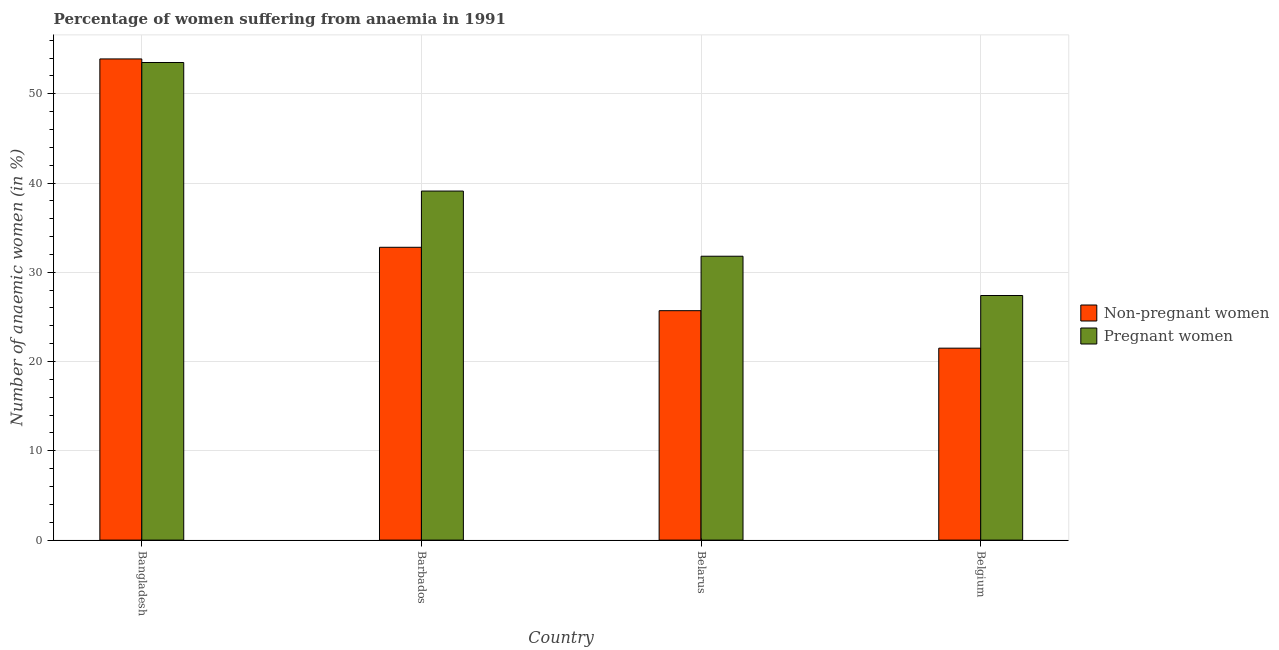How many different coloured bars are there?
Give a very brief answer. 2. Are the number of bars per tick equal to the number of legend labels?
Provide a succinct answer. Yes. How many bars are there on the 1st tick from the right?
Make the answer very short. 2. What is the label of the 3rd group of bars from the left?
Ensure brevity in your answer.  Belarus. What is the percentage of non-pregnant anaemic women in Belarus?
Provide a succinct answer. 25.7. Across all countries, what is the maximum percentage of pregnant anaemic women?
Your answer should be compact. 53.5. Across all countries, what is the minimum percentage of pregnant anaemic women?
Keep it short and to the point. 27.4. In which country was the percentage of pregnant anaemic women maximum?
Give a very brief answer. Bangladesh. What is the total percentage of pregnant anaemic women in the graph?
Your answer should be very brief. 151.8. What is the difference between the percentage of pregnant anaemic women in Bangladesh and that in Barbados?
Provide a succinct answer. 14.4. What is the difference between the percentage of non-pregnant anaemic women in Belarus and the percentage of pregnant anaemic women in Belgium?
Your answer should be compact. -1.7. What is the average percentage of non-pregnant anaemic women per country?
Give a very brief answer. 33.47. What is the difference between the percentage of pregnant anaemic women and percentage of non-pregnant anaemic women in Belgium?
Offer a very short reply. 5.9. In how many countries, is the percentage of non-pregnant anaemic women greater than 22 %?
Provide a short and direct response. 3. What is the ratio of the percentage of non-pregnant anaemic women in Bangladesh to that in Barbados?
Your answer should be compact. 1.64. Is the percentage of pregnant anaemic women in Barbados less than that in Belgium?
Offer a very short reply. No. Is the difference between the percentage of non-pregnant anaemic women in Bangladesh and Belgium greater than the difference between the percentage of pregnant anaemic women in Bangladesh and Belgium?
Make the answer very short. Yes. What is the difference between the highest and the second highest percentage of pregnant anaemic women?
Give a very brief answer. 14.4. What is the difference between the highest and the lowest percentage of non-pregnant anaemic women?
Offer a very short reply. 32.4. What does the 2nd bar from the left in Belgium represents?
Your response must be concise. Pregnant women. What does the 1st bar from the right in Bangladesh represents?
Keep it short and to the point. Pregnant women. Are all the bars in the graph horizontal?
Offer a terse response. No. How many countries are there in the graph?
Offer a terse response. 4. Does the graph contain any zero values?
Ensure brevity in your answer.  No. Does the graph contain grids?
Your answer should be compact. Yes. Where does the legend appear in the graph?
Offer a terse response. Center right. How many legend labels are there?
Offer a very short reply. 2. What is the title of the graph?
Give a very brief answer. Percentage of women suffering from anaemia in 1991. Does "Electricity" appear as one of the legend labels in the graph?
Offer a terse response. No. What is the label or title of the Y-axis?
Offer a terse response. Number of anaemic women (in %). What is the Number of anaemic women (in %) in Non-pregnant women in Bangladesh?
Your answer should be very brief. 53.9. What is the Number of anaemic women (in %) in Pregnant women in Bangladesh?
Your answer should be very brief. 53.5. What is the Number of anaemic women (in %) of Non-pregnant women in Barbados?
Give a very brief answer. 32.8. What is the Number of anaemic women (in %) of Pregnant women in Barbados?
Your answer should be compact. 39.1. What is the Number of anaemic women (in %) in Non-pregnant women in Belarus?
Provide a short and direct response. 25.7. What is the Number of anaemic women (in %) in Pregnant women in Belarus?
Give a very brief answer. 31.8. What is the Number of anaemic women (in %) of Pregnant women in Belgium?
Provide a succinct answer. 27.4. Across all countries, what is the maximum Number of anaemic women (in %) of Non-pregnant women?
Offer a very short reply. 53.9. Across all countries, what is the maximum Number of anaemic women (in %) of Pregnant women?
Offer a terse response. 53.5. Across all countries, what is the minimum Number of anaemic women (in %) in Pregnant women?
Your answer should be very brief. 27.4. What is the total Number of anaemic women (in %) in Non-pregnant women in the graph?
Offer a terse response. 133.9. What is the total Number of anaemic women (in %) of Pregnant women in the graph?
Your response must be concise. 151.8. What is the difference between the Number of anaemic women (in %) of Non-pregnant women in Bangladesh and that in Barbados?
Keep it short and to the point. 21.1. What is the difference between the Number of anaemic women (in %) of Pregnant women in Bangladesh and that in Barbados?
Provide a short and direct response. 14.4. What is the difference between the Number of anaemic women (in %) of Non-pregnant women in Bangladesh and that in Belarus?
Provide a succinct answer. 28.2. What is the difference between the Number of anaemic women (in %) of Pregnant women in Bangladesh and that in Belarus?
Your response must be concise. 21.7. What is the difference between the Number of anaemic women (in %) of Non-pregnant women in Bangladesh and that in Belgium?
Ensure brevity in your answer.  32.4. What is the difference between the Number of anaemic women (in %) in Pregnant women in Bangladesh and that in Belgium?
Your answer should be compact. 26.1. What is the difference between the Number of anaemic women (in %) in Pregnant women in Barbados and that in Belarus?
Provide a succinct answer. 7.3. What is the difference between the Number of anaemic women (in %) in Non-pregnant women in Barbados and that in Belgium?
Keep it short and to the point. 11.3. What is the difference between the Number of anaemic women (in %) of Pregnant women in Barbados and that in Belgium?
Ensure brevity in your answer.  11.7. What is the difference between the Number of anaemic women (in %) in Non-pregnant women in Belarus and that in Belgium?
Keep it short and to the point. 4.2. What is the difference between the Number of anaemic women (in %) in Non-pregnant women in Bangladesh and the Number of anaemic women (in %) in Pregnant women in Barbados?
Your answer should be very brief. 14.8. What is the difference between the Number of anaemic women (in %) in Non-pregnant women in Bangladesh and the Number of anaemic women (in %) in Pregnant women in Belarus?
Keep it short and to the point. 22.1. What is the difference between the Number of anaemic women (in %) in Non-pregnant women in Barbados and the Number of anaemic women (in %) in Pregnant women in Belarus?
Provide a succinct answer. 1. What is the difference between the Number of anaemic women (in %) of Non-pregnant women in Barbados and the Number of anaemic women (in %) of Pregnant women in Belgium?
Make the answer very short. 5.4. What is the difference between the Number of anaemic women (in %) of Non-pregnant women in Belarus and the Number of anaemic women (in %) of Pregnant women in Belgium?
Provide a short and direct response. -1.7. What is the average Number of anaemic women (in %) in Non-pregnant women per country?
Ensure brevity in your answer.  33.48. What is the average Number of anaemic women (in %) of Pregnant women per country?
Your response must be concise. 37.95. What is the difference between the Number of anaemic women (in %) in Non-pregnant women and Number of anaemic women (in %) in Pregnant women in Bangladesh?
Give a very brief answer. 0.4. What is the difference between the Number of anaemic women (in %) of Non-pregnant women and Number of anaemic women (in %) of Pregnant women in Barbados?
Ensure brevity in your answer.  -6.3. What is the ratio of the Number of anaemic women (in %) in Non-pregnant women in Bangladesh to that in Barbados?
Your answer should be very brief. 1.64. What is the ratio of the Number of anaemic women (in %) of Pregnant women in Bangladesh to that in Barbados?
Your answer should be compact. 1.37. What is the ratio of the Number of anaemic women (in %) in Non-pregnant women in Bangladesh to that in Belarus?
Ensure brevity in your answer.  2.1. What is the ratio of the Number of anaemic women (in %) in Pregnant women in Bangladesh to that in Belarus?
Provide a short and direct response. 1.68. What is the ratio of the Number of anaemic women (in %) in Non-pregnant women in Bangladesh to that in Belgium?
Provide a short and direct response. 2.51. What is the ratio of the Number of anaemic women (in %) in Pregnant women in Bangladesh to that in Belgium?
Offer a terse response. 1.95. What is the ratio of the Number of anaemic women (in %) in Non-pregnant women in Barbados to that in Belarus?
Offer a terse response. 1.28. What is the ratio of the Number of anaemic women (in %) in Pregnant women in Barbados to that in Belarus?
Give a very brief answer. 1.23. What is the ratio of the Number of anaemic women (in %) in Non-pregnant women in Barbados to that in Belgium?
Give a very brief answer. 1.53. What is the ratio of the Number of anaemic women (in %) in Pregnant women in Barbados to that in Belgium?
Your response must be concise. 1.43. What is the ratio of the Number of anaemic women (in %) of Non-pregnant women in Belarus to that in Belgium?
Offer a terse response. 1.2. What is the ratio of the Number of anaemic women (in %) of Pregnant women in Belarus to that in Belgium?
Offer a very short reply. 1.16. What is the difference between the highest and the second highest Number of anaemic women (in %) in Non-pregnant women?
Make the answer very short. 21.1. What is the difference between the highest and the second highest Number of anaemic women (in %) in Pregnant women?
Your answer should be compact. 14.4. What is the difference between the highest and the lowest Number of anaemic women (in %) of Non-pregnant women?
Offer a terse response. 32.4. What is the difference between the highest and the lowest Number of anaemic women (in %) in Pregnant women?
Give a very brief answer. 26.1. 